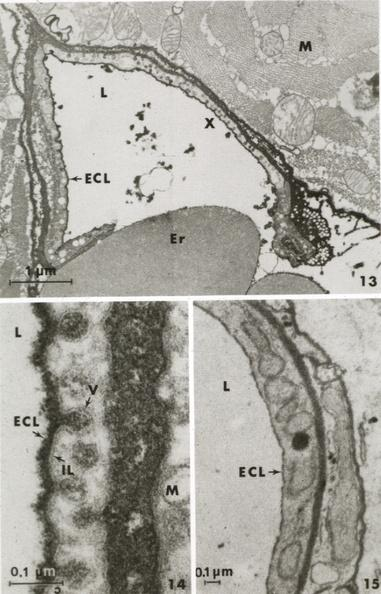does marfans syndrome show muscle ruthenium red to illustrate glycocalyx?
Answer the question using a single word or phrase. No 